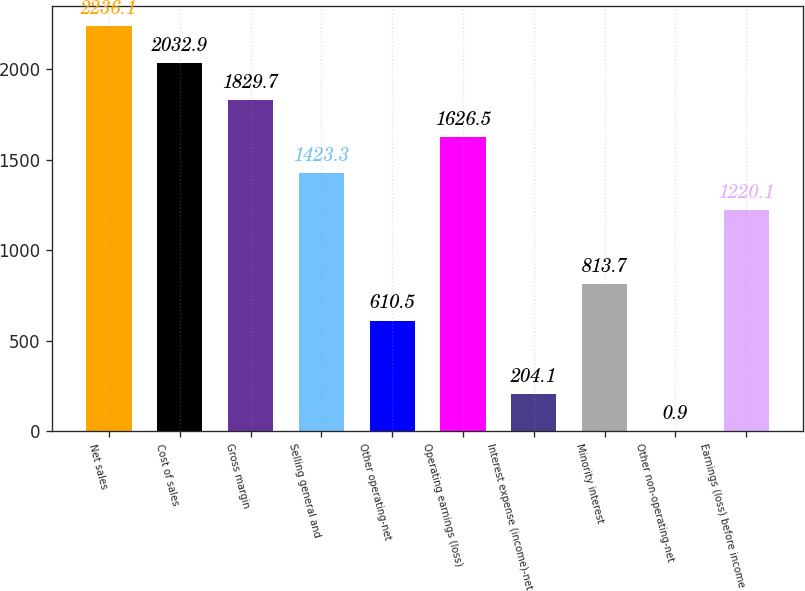Convert chart to OTSL. <chart><loc_0><loc_0><loc_500><loc_500><bar_chart><fcel>Net sales<fcel>Cost of sales<fcel>Gross margin<fcel>Selling general and<fcel>Other operating-net<fcel>Operating earnings (loss)<fcel>Interest expense (income)-net<fcel>Minority interest<fcel>Other non-operating-net<fcel>Earnings (loss) before income<nl><fcel>2236.1<fcel>2032.9<fcel>1829.7<fcel>1423.3<fcel>610.5<fcel>1626.5<fcel>204.1<fcel>813.7<fcel>0.9<fcel>1220.1<nl></chart> 